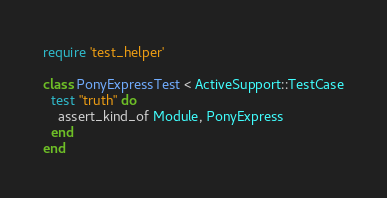Convert code to text. <code><loc_0><loc_0><loc_500><loc_500><_Ruby_>require 'test_helper'

class PonyExpressTest < ActiveSupport::TestCase
  test "truth" do
    assert_kind_of Module, PonyExpress
  end
end
</code> 